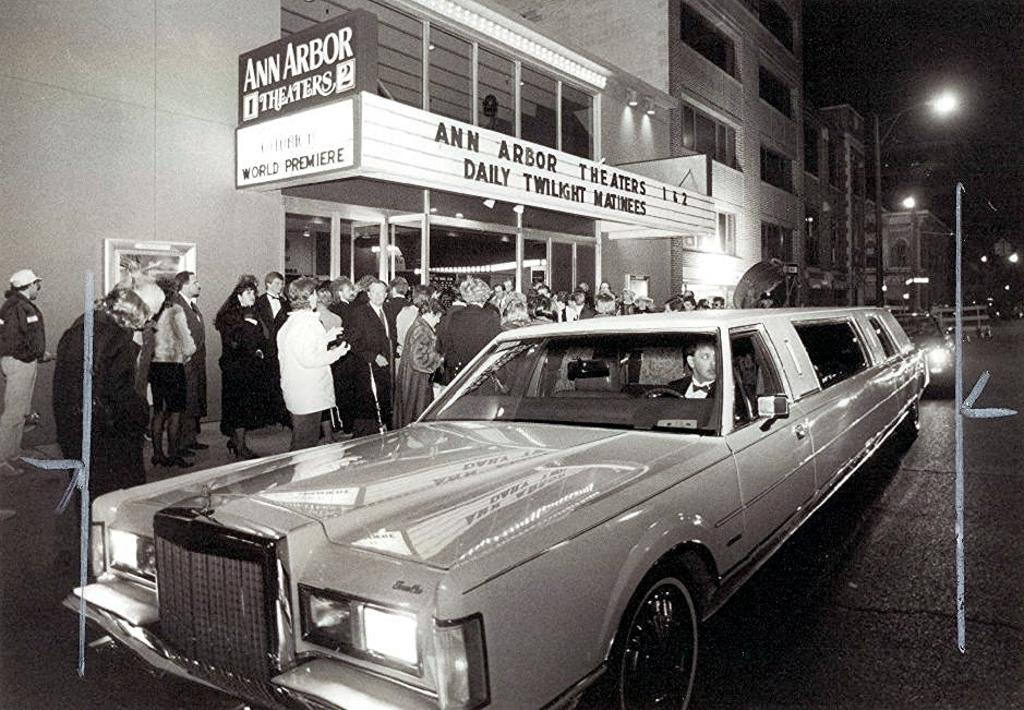What can be seen on the road in the image? There are vehicles on the road in the image. What structures are present alongside the road? Light poles are visible in the image. What are the people in the image doing? There are people standing on the surface in the image. What type of advertisement is present in the image? A hoarding is present in the image. What type of man-made structures can be seen in the image? There are buildings in the image. Where are the babies being kept in the image? There are no babies present in the image. What type of jail can be seen in the image? There is no jail present in the image. 